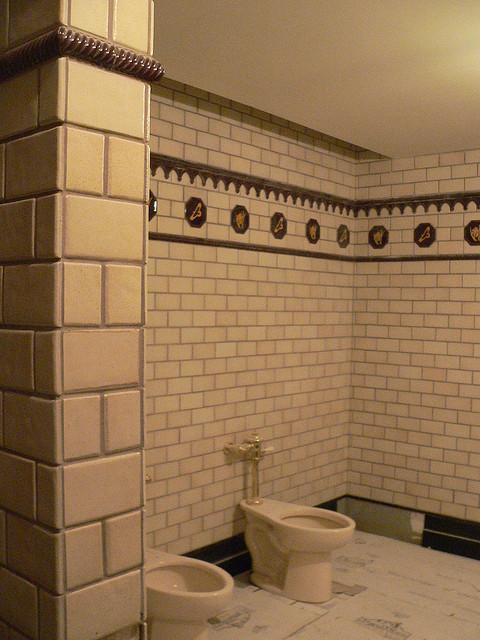Is there a mirror?
Write a very short answer. No. Are the toilets ready to be used?
Quick response, please. Yes. What is the main color in the bathroom?
Keep it brief. White. What shape is above the circles?
Quick response, please. Rectangle. What color are the tiles?
Write a very short answer. White. Is this a public bathroom?
Keep it brief. Yes. What is in the middle of the room?
Quick response, please. Toilet. What color is the wall in the picture? White and ____?
Short answer required. Black. Is this a public restroom?
Write a very short answer. Yes. What color is dominant?
Short answer required. White. Does the toilet work?
Write a very short answer. Yes. Men's or women's restroom?
Write a very short answer. Men's. Why does this bathroom lack privacy?
Be succinct. No door. Who is depicted on the tiles?
Write a very short answer. No one. Is there a shower?
Answer briefly. No. Is the tile new?
Answer briefly. No. Is there a mirror in this bathroom?
Be succinct. No. Is this a rustic bathroom?
Keep it brief. No. How many toilets are there?
Short answer required. 2. Is there a bench?
Concise answer only. No. What color are the walls?
Keep it brief. White. Is this a museum?
Quick response, please. No. What is the wall decorated with?
Quick response, please. Tile. Is this bathroom nice?
Concise answer only. Yes. What drawing is on the wall?
Write a very short answer. None. 